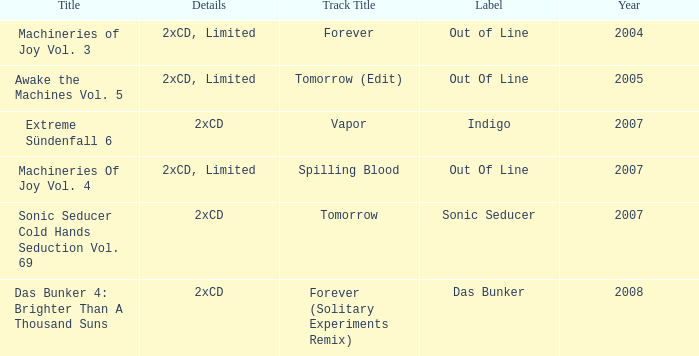Which track title has a year lesser thsn 2005? Forever. 